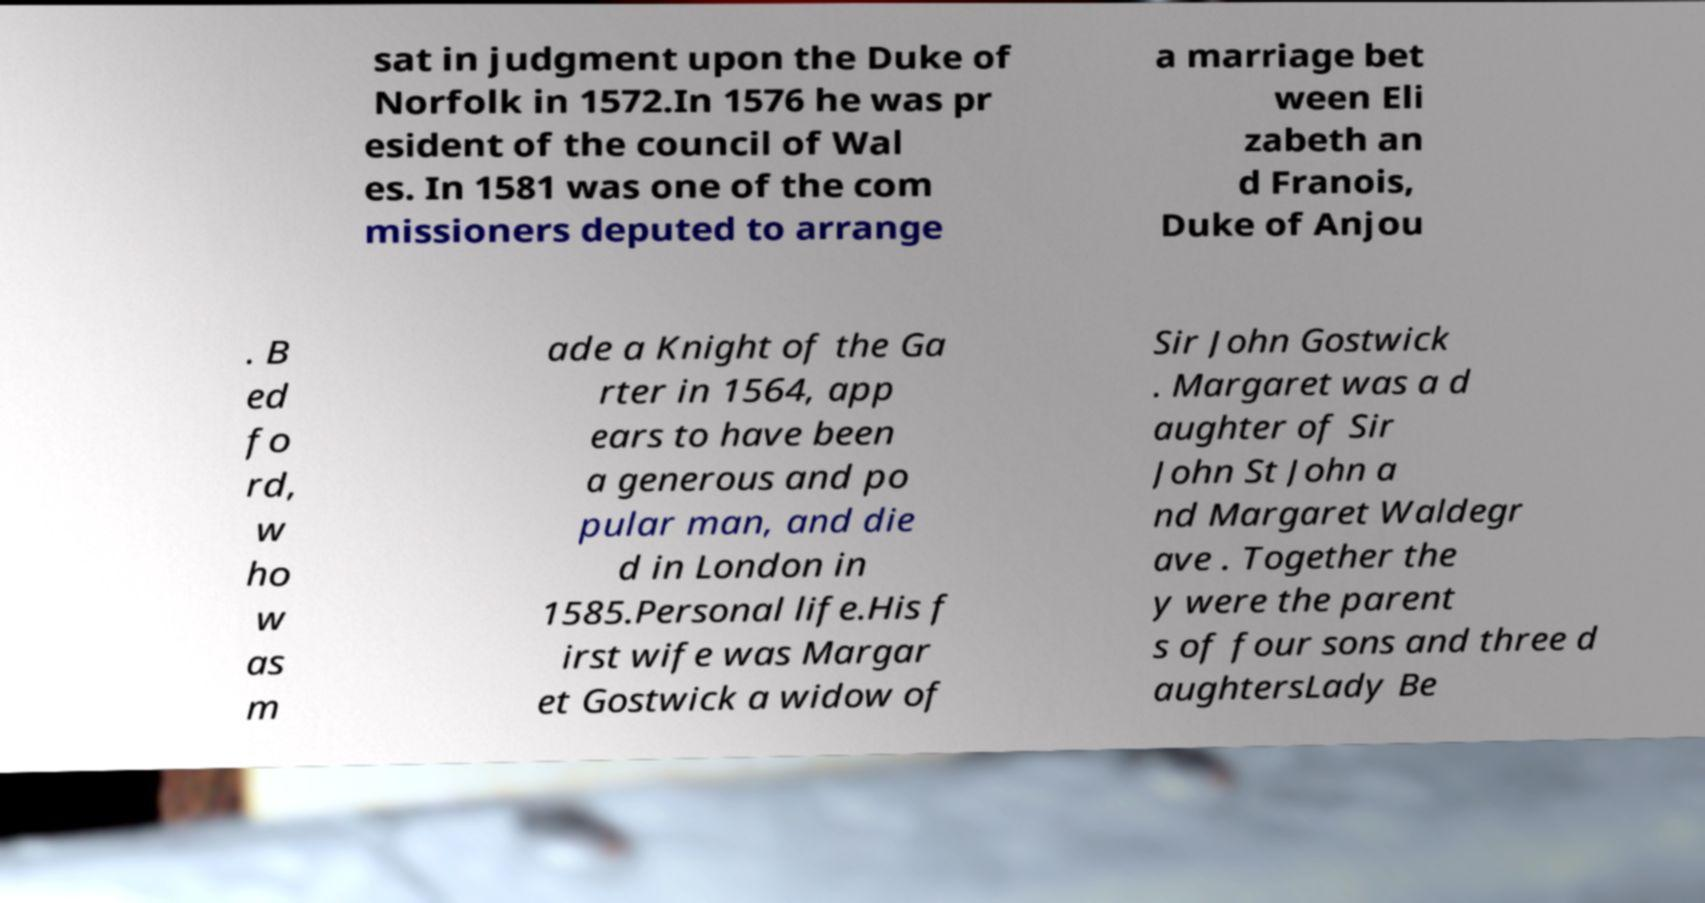Could you assist in decoding the text presented in this image and type it out clearly? sat in judgment upon the Duke of Norfolk in 1572.In 1576 he was pr esident of the council of Wal es. In 1581 was one of the com missioners deputed to arrange a marriage bet ween Eli zabeth an d Franois, Duke of Anjou . B ed fo rd, w ho w as m ade a Knight of the Ga rter in 1564, app ears to have been a generous and po pular man, and die d in London in 1585.Personal life.His f irst wife was Margar et Gostwick a widow of Sir John Gostwick . Margaret was a d aughter of Sir John St John a nd Margaret Waldegr ave . Together the y were the parent s of four sons and three d aughtersLady Be 